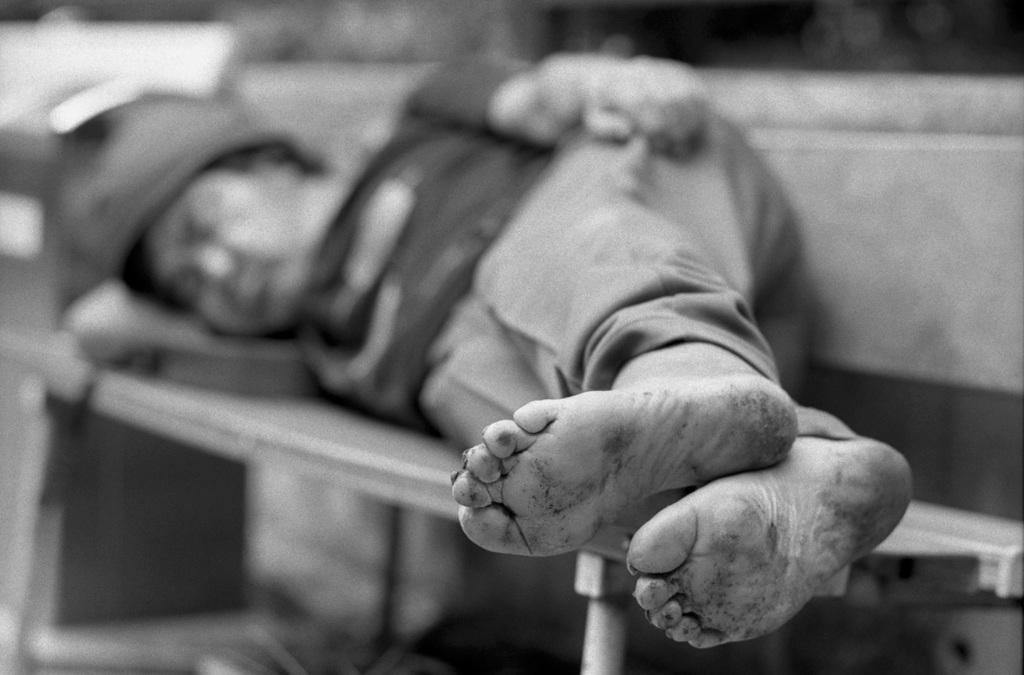Who or what is present in the image? There is a person in the image. What is the person doing in the image? The person is lying on a bench. What is the purpose of the fang in the image? There is no fang present in the image. What type of stew is being prepared in the image? There is no stew or cooking activity depicted in the image. 